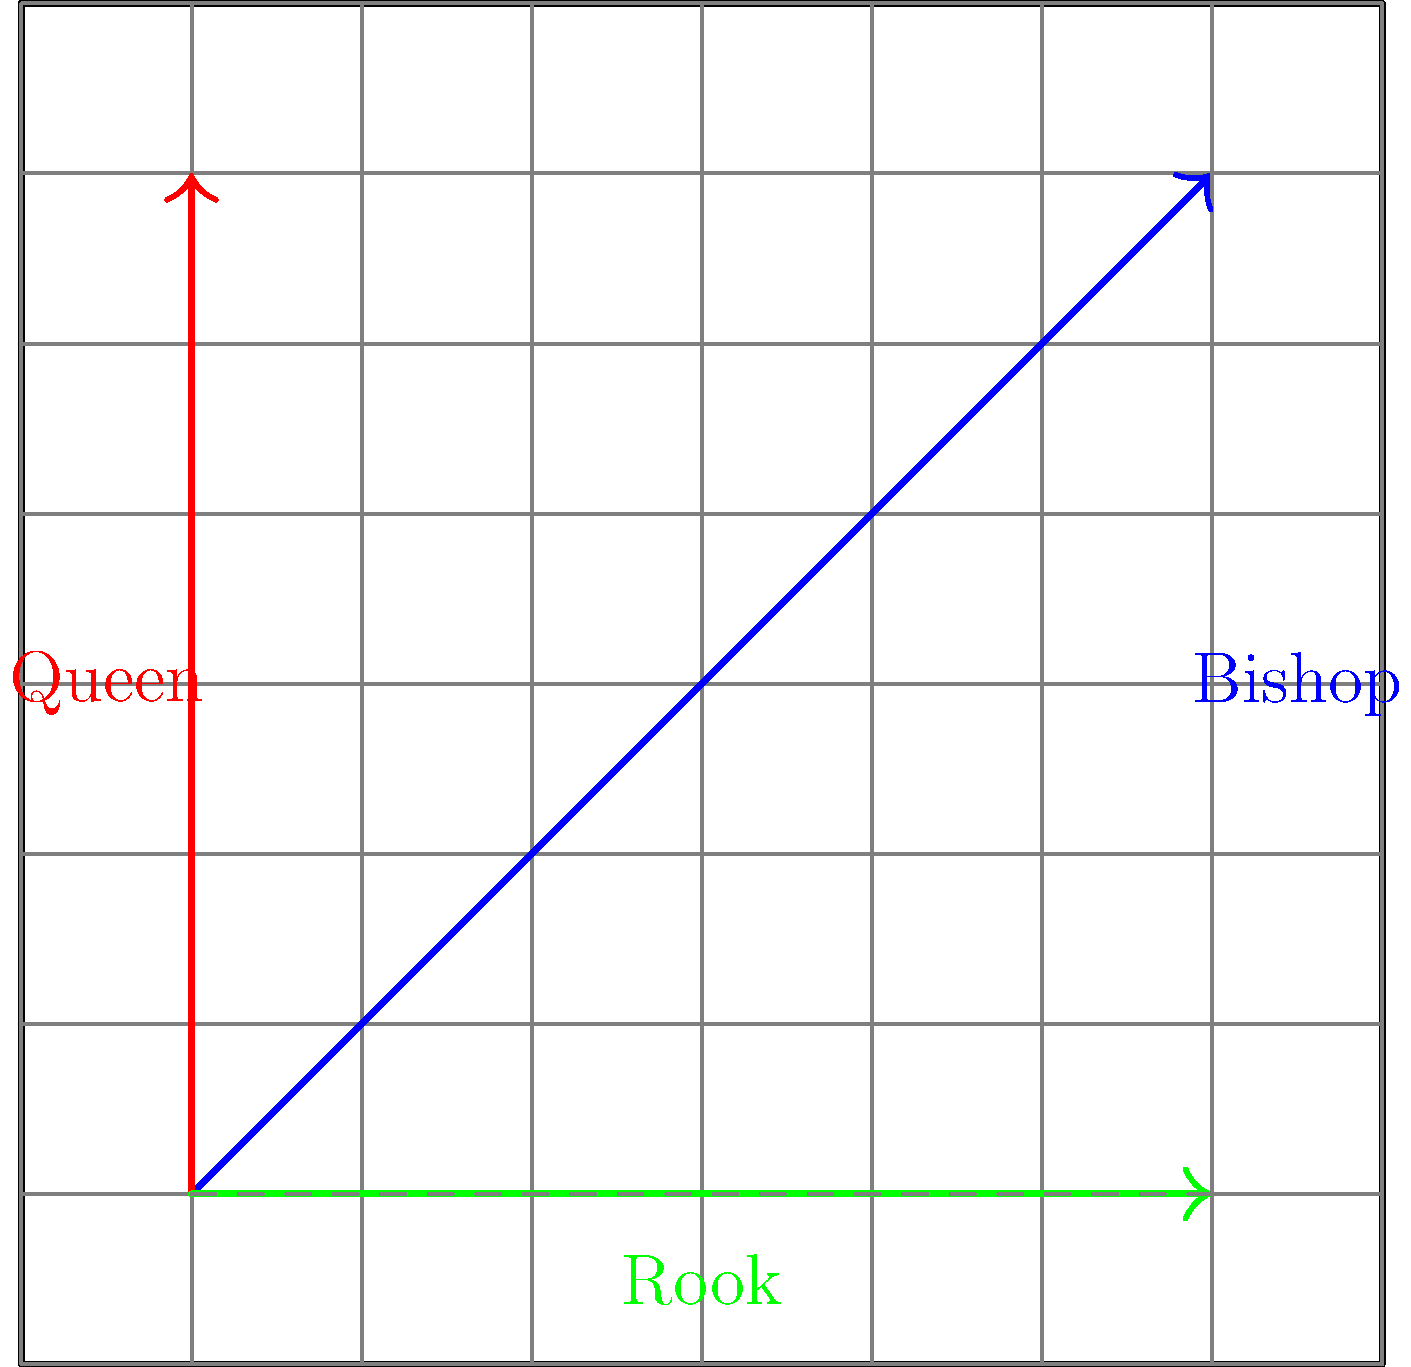In a standard 8x8 chess board, compare the movements of a Queen, a Rook, and a Bishop from the bottom-left corner (a1) to the top-right corner (h8). Which piece(s) can reach the destination in a single move, and what is the magnitude of the displacement vector for each piece's movement? Let's analyze the movement of each piece step-by-step:

1. Queen (red vector):
   - Can move in any direction (horizontally, vertically, or diagonally)
   - Can reach h8 in a single move along the diagonal
   - Displacement vector: $\vec{v}_Q = (7, 7)$
   - Magnitude: $|\vec{v}_Q| = \sqrt{7^2 + 7^2} = 7\sqrt{2}$

2. Rook (green vector):
   - Can only move horizontally or vertically
   - Needs two moves to reach h8 (e.g., a1 to h1, then h1 to h8)
   - Total displacement vector: $\vec{v}_R = (7, 7)$
   - Magnitude: $|\vec{v}_R| = \sqrt{7^2 + 7^2} = 7\sqrt{2}$

3. Bishop (blue vector):
   - Can only move diagonally
   - Can reach h8 in a single move along the diagonal
   - Displacement vector: $\vec{v}_B = (7, 7)$
   - Magnitude: $|\vec{v}_B| = \sqrt{7^2 + 7^2} = 7\sqrt{2}$

Comparing the movements:
- The Queen and Bishop can reach h8 in a single move.
- The Rook requires two moves to reach h8.
- All three pieces have the same displacement vector magnitude of $7\sqrt{2}$.
Answer: Queen and Bishop; $7\sqrt{2}$ for all pieces 